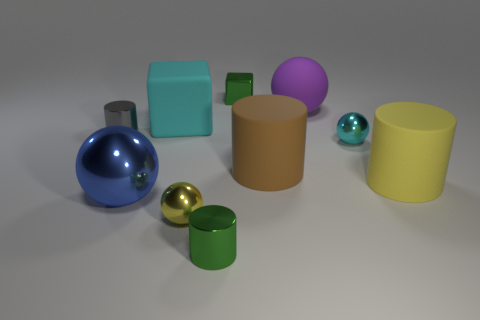Subtract all large matte spheres. How many spheres are left? 3 Subtract all yellow cylinders. How many cylinders are left? 3 Subtract all blocks. How many objects are left? 8 Subtract 2 cubes. How many cubes are left? 0 Subtract all tiny spheres. Subtract all shiny objects. How many objects are left? 2 Add 8 large cyan things. How many large cyan things are left? 9 Add 2 gray metal cylinders. How many gray metal cylinders exist? 3 Subtract 0 red cylinders. How many objects are left? 10 Subtract all purple balls. Subtract all yellow cubes. How many balls are left? 3 Subtract all red spheres. How many cyan cylinders are left? 0 